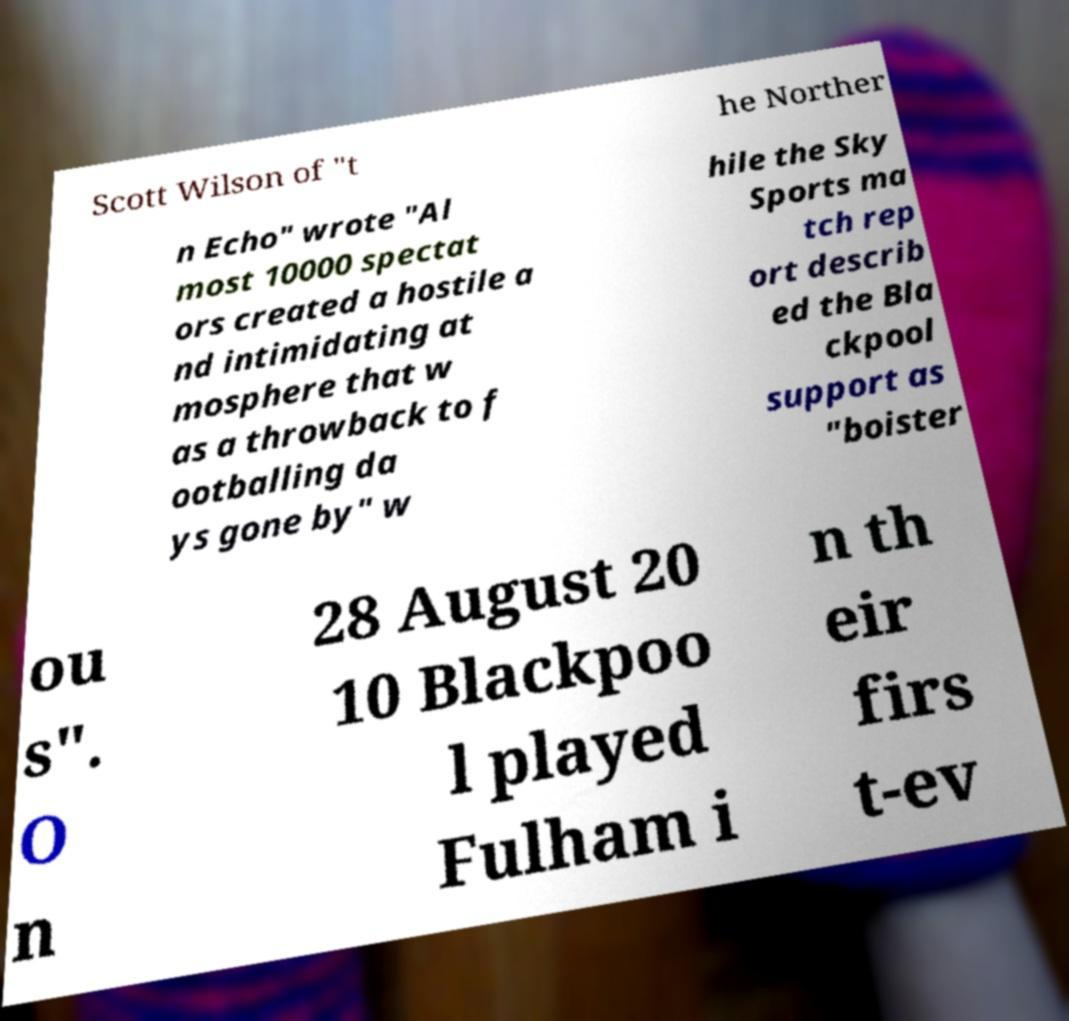What messages or text are displayed in this image? I need them in a readable, typed format. Scott Wilson of "t he Norther n Echo" wrote "Al most 10000 spectat ors created a hostile a nd intimidating at mosphere that w as a throwback to f ootballing da ys gone by" w hile the Sky Sports ma tch rep ort describ ed the Bla ckpool support as "boister ou s". O n 28 August 20 10 Blackpoo l played Fulham i n th eir firs t-ev 